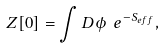Convert formula to latex. <formula><loc_0><loc_0><loc_500><loc_500>Z [ 0 ] = \int D \phi \ e ^ { - S _ { e f f } } ,</formula> 